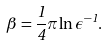Convert formula to latex. <formula><loc_0><loc_0><loc_500><loc_500>\beta = \frac { 1 } { 4 } \pi \ln \epsilon ^ { - 1 } .</formula> 